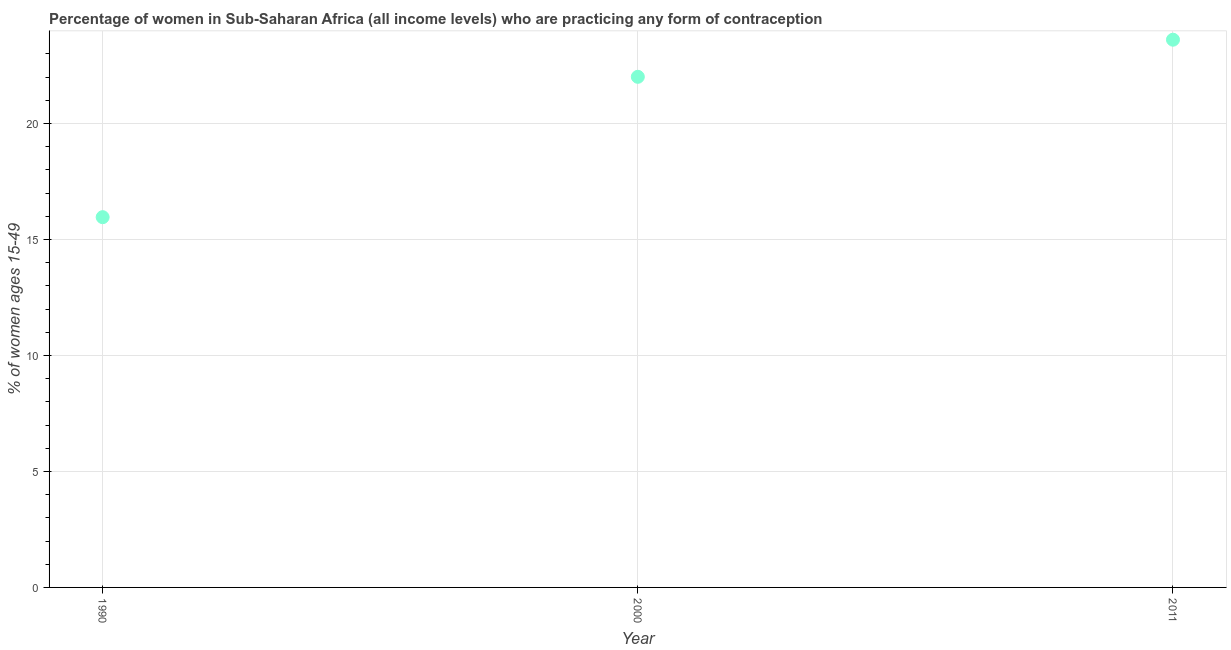What is the contraceptive prevalence in 2000?
Offer a terse response. 22.01. Across all years, what is the maximum contraceptive prevalence?
Keep it short and to the point. 23.61. Across all years, what is the minimum contraceptive prevalence?
Your response must be concise. 15.96. In which year was the contraceptive prevalence minimum?
Provide a succinct answer. 1990. What is the sum of the contraceptive prevalence?
Offer a terse response. 61.59. What is the difference between the contraceptive prevalence in 2000 and 2011?
Give a very brief answer. -1.6. What is the average contraceptive prevalence per year?
Give a very brief answer. 20.53. What is the median contraceptive prevalence?
Keep it short and to the point. 22.01. In how many years, is the contraceptive prevalence greater than 14 %?
Provide a succinct answer. 3. Do a majority of the years between 2000 and 2011 (inclusive) have contraceptive prevalence greater than 9 %?
Offer a very short reply. Yes. What is the ratio of the contraceptive prevalence in 1990 to that in 2000?
Ensure brevity in your answer.  0.73. What is the difference between the highest and the second highest contraceptive prevalence?
Offer a very short reply. 1.6. Is the sum of the contraceptive prevalence in 1990 and 2011 greater than the maximum contraceptive prevalence across all years?
Your response must be concise. Yes. What is the difference between the highest and the lowest contraceptive prevalence?
Offer a terse response. 7.65. Does the contraceptive prevalence monotonically increase over the years?
Make the answer very short. Yes. What is the difference between two consecutive major ticks on the Y-axis?
Offer a terse response. 5. What is the title of the graph?
Make the answer very short. Percentage of women in Sub-Saharan Africa (all income levels) who are practicing any form of contraception. What is the label or title of the Y-axis?
Give a very brief answer. % of women ages 15-49. What is the % of women ages 15-49 in 1990?
Your answer should be very brief. 15.96. What is the % of women ages 15-49 in 2000?
Offer a very short reply. 22.01. What is the % of women ages 15-49 in 2011?
Offer a terse response. 23.61. What is the difference between the % of women ages 15-49 in 1990 and 2000?
Your answer should be very brief. -6.05. What is the difference between the % of women ages 15-49 in 1990 and 2011?
Keep it short and to the point. -7.65. What is the difference between the % of women ages 15-49 in 2000 and 2011?
Make the answer very short. -1.6. What is the ratio of the % of women ages 15-49 in 1990 to that in 2000?
Make the answer very short. 0.72. What is the ratio of the % of women ages 15-49 in 1990 to that in 2011?
Your answer should be very brief. 0.68. What is the ratio of the % of women ages 15-49 in 2000 to that in 2011?
Provide a succinct answer. 0.93. 